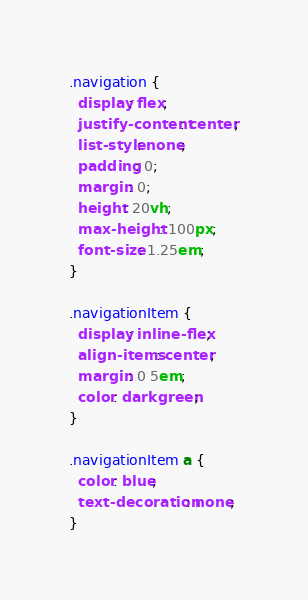Convert code to text. <code><loc_0><loc_0><loc_500><loc_500><_CSS_>.navigation {
  display: flex;
  justify-content: center;
  list-style: none;
  padding: 0;
  margin: 0;
  height: 20vh;
  max-height: 100px;
  font-size: 1.25em;
}

.navigationItem {
  display: inline-flex;
  align-items: center;
  margin: 0 5em;
  color: darkgreen;
}

.navigationItem a {
  color: blue;
  text-decoration: none;
}
</code> 